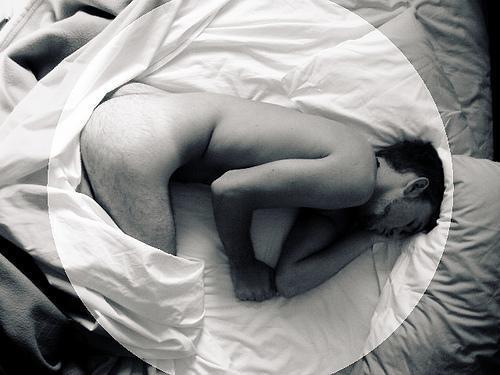How many people are in the picture?
Give a very brief answer. 1. 